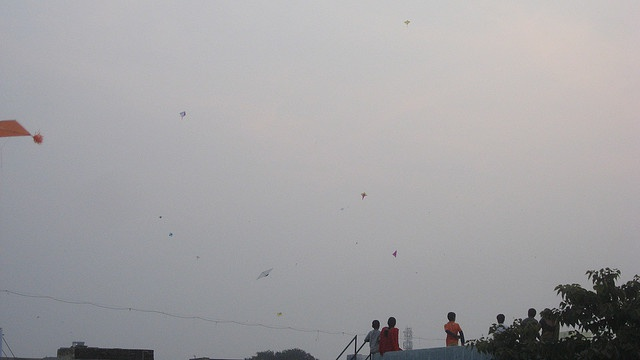Describe the objects in this image and their specific colors. I can see kite in darkgray, gray, and lightgray tones, people in darkgray, black, and gray tones, people in darkgray, black, and gray tones, people in darkgray, maroon, black, and gray tones, and kite in darkgray and brown tones in this image. 